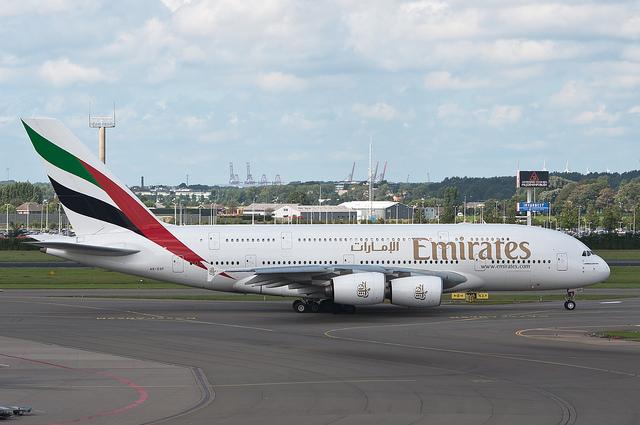What is the name of the airline?
Short answer required. Emirates. Are those cranes on the background?
Quick response, please. Yes. What are the letters on this airplane?
Short answer required. Emirates. Is this at an airport?
Keep it brief. Yes. What is the plane's airline name?
Give a very brief answer. Emirates. What type of transportation is this?
Answer briefly. Airplane. What is the color of the plane?
Short answer required. White. What color is the sign that says E?
Quick response, please. Gold. 